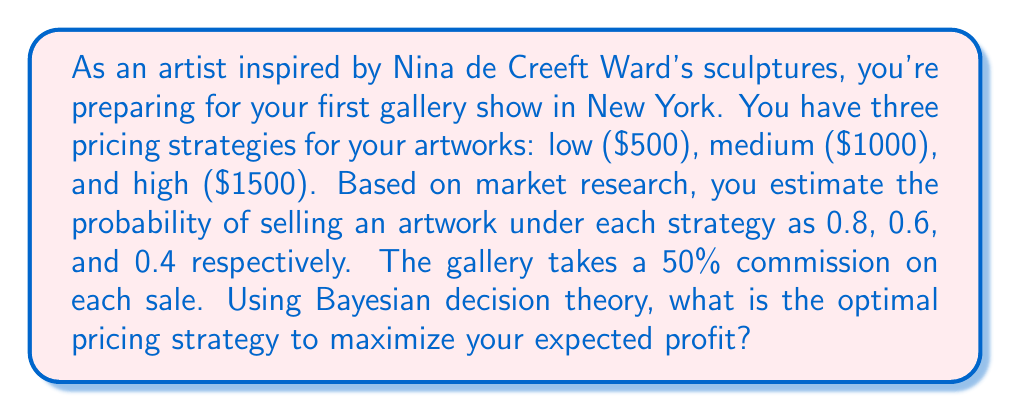Give your solution to this math problem. To solve this problem using Bayesian decision theory, we need to calculate the expected value (EV) for each pricing strategy and choose the one with the highest EV.

1. Calculate the artist's profit for each price point:
   - Low: $500 * 0.5 = $250
   - Medium: $1000 * 0.5 = $500
   - High: $1500 * 0.5 = $750

2. Calculate the expected value for each strategy:
   
   $$ EV = \text{Probability of Sale} \times \text{Profit} $$

   - Low: $EV_L = 0.8 \times 250 = 200$
   - Medium: $EV_M = 0.6 \times 500 = 300$
   - High: $EV_H = 0.4 \times 750 = 300$

3. Compare the expected values:
   The medium and high pricing strategies both have the highest expected value of $300.

4. In case of a tie, we can consider additional factors:
   - The medium price strategy has a higher probability of sale, which may lead to more exposure and future opportunities.
   - The high price strategy, if successful, establishes a higher perceived value for your art.

Given the information provided, both the medium and high pricing strategies are optimal from a purely mathematical standpoint. However, as an emerging artist, the medium pricing strategy might be more beneficial for building a reputation and client base in the competitive New York art scene.
Answer: The optimal pricing strategy is the medium price ($1000) with an expected value of $300, although the high price ($1500) strategy yields the same expected value. The medium price is recommended for an emerging artist to balance profit potential with higher sale probability. 